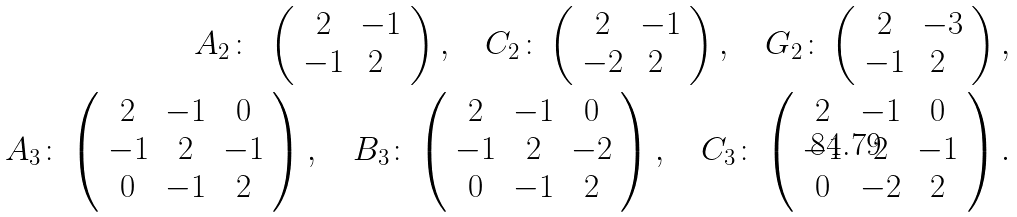<formula> <loc_0><loc_0><loc_500><loc_500>A _ { 2 } \colon \ \left ( \begin{array} { c c } 2 & - 1 \\ - 1 & 2 \ \end{array} \right ) , \quad C _ { 2 } \colon \left ( \begin{array} { c c } 2 & - 1 \\ - 2 & 2 \ \end{array} \right ) , \quad G _ { 2 } \colon \left ( \begin{array} { c c } 2 & - 3 \\ - 1 & 2 \ \end{array} \right ) , \\ A _ { 3 } \colon \left ( \begin{array} { c c c } 2 & - 1 & 0 \\ - 1 & 2 & - 1 \\ 0 & - 1 & 2 \end{array} \right ) , \quad B _ { 3 } \colon \left ( \begin{array} { c c c } 2 & - 1 & 0 \\ - 1 & 2 & - 2 \\ 0 & - 1 & 2 \end{array} \right ) , \quad C _ { 3 } \colon \left ( \begin{array} { c c c } 2 & - 1 & 0 \\ - 1 & 2 & - 1 \\ 0 & - 2 & 2 \end{array} \right ) .</formula> 